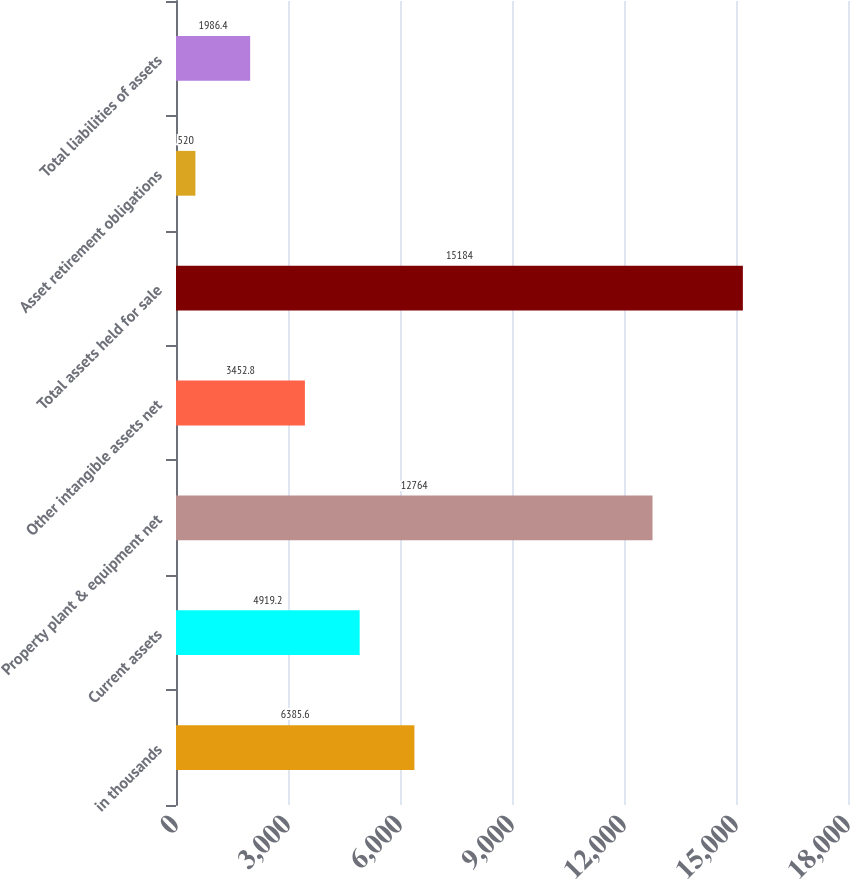Convert chart. <chart><loc_0><loc_0><loc_500><loc_500><bar_chart><fcel>in thousands<fcel>Current assets<fcel>Property plant & equipment net<fcel>Other intangible assets net<fcel>Total assets held for sale<fcel>Asset retirement obligations<fcel>Total liabilities of assets<nl><fcel>6385.6<fcel>4919.2<fcel>12764<fcel>3452.8<fcel>15184<fcel>520<fcel>1986.4<nl></chart> 